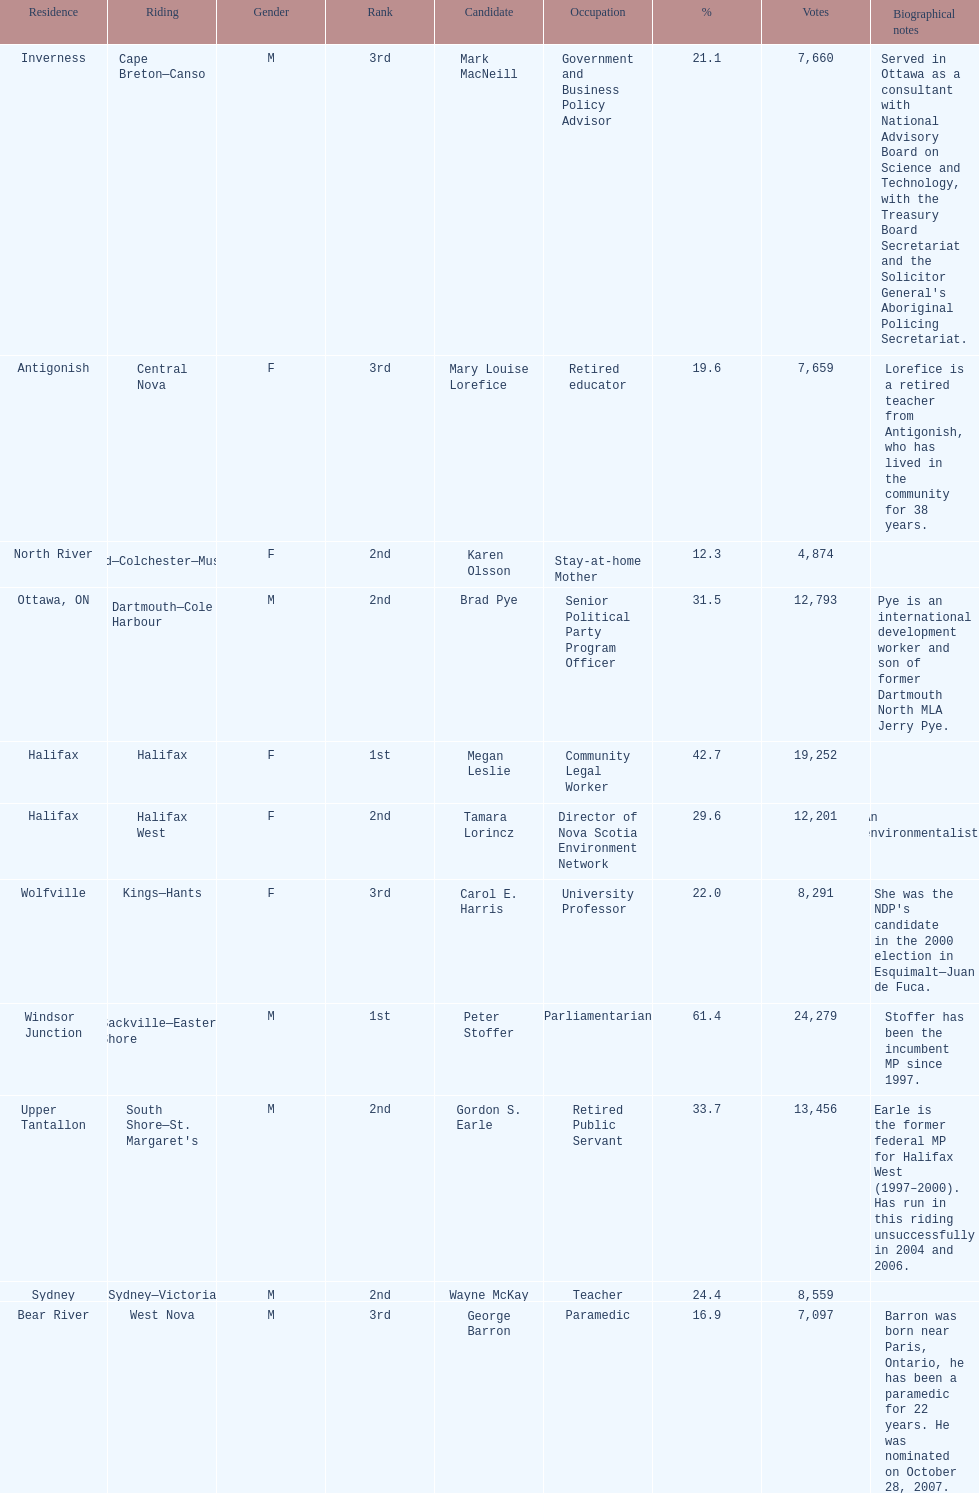Could you help me parse every detail presented in this table? {'header': ['Residence', 'Riding', 'Gender', 'Rank', 'Candidate', 'Occupation', '%', 'Votes', 'Biographical notes'], 'rows': [['Inverness', 'Cape Breton—Canso', 'M', '3rd', 'Mark MacNeill', 'Government and Business Policy Advisor', '21.1', '7,660', "Served in Ottawa as a consultant with National Advisory Board on Science and Technology, with the Treasury Board Secretariat and the Solicitor General's Aboriginal Policing Secretariat."], ['Antigonish', 'Central Nova', 'F', '3rd', 'Mary Louise Lorefice', 'Retired educator', '19.6', '7,659', 'Lorefice is a retired teacher from Antigonish, who has lived in the community for 38 years.'], ['North River', 'Cumberland—Colchester—Musquodoboit Valley', 'F', '2nd', 'Karen Olsson', 'Stay-at-home Mother', '12.3', '4,874', ''], ['Ottawa, ON', 'Dartmouth—Cole Harbour', 'M', '2nd', 'Brad Pye', 'Senior Political Party Program Officer', '31.5', '12,793', 'Pye is an international development worker and son of former Dartmouth North MLA Jerry Pye.'], ['Halifax', 'Halifax', 'F', '1st', 'Megan Leslie', 'Community Legal Worker', '42.7', '19,252', ''], ['Halifax', 'Halifax West', 'F', '2nd', 'Tamara Lorincz', 'Director of Nova Scotia Environment Network', '29.6', '12,201', 'An environmentalist.'], ['Wolfville', 'Kings—Hants', 'F', '3rd', 'Carol E. Harris', 'University Professor', '22.0', '8,291', "She was the NDP's candidate in the 2000 election in Esquimalt—Juan de Fuca."], ['Windsor Junction', 'Sackville—Eastern Shore', 'M', '1st', 'Peter Stoffer', 'Parliamentarian', '61.4', '24,279', 'Stoffer has been the incumbent MP since 1997.'], ['Upper Tantallon', "South Shore—St. Margaret's", 'M', '2nd', 'Gordon S. Earle', 'Retired Public Servant', '33.7', '13,456', 'Earle is the former federal MP for Halifax West (1997–2000). Has run in this riding unsuccessfully in 2004 and 2006.'], ['Sydney', 'Sydney—Victoria', 'M', '2nd', 'Wayne McKay', 'Teacher', '24.4', '8,559', ''], ['Bear River', 'West Nova', 'M', '3rd', 'George Barron', 'Paramedic', '16.9', '7,097', 'Barron was born near Paris, Ontario, he has been a paramedic for 22 years. He was nominated on October 28, 2007.']]} Who has the most votes? Sackville-Eastern Shore. 